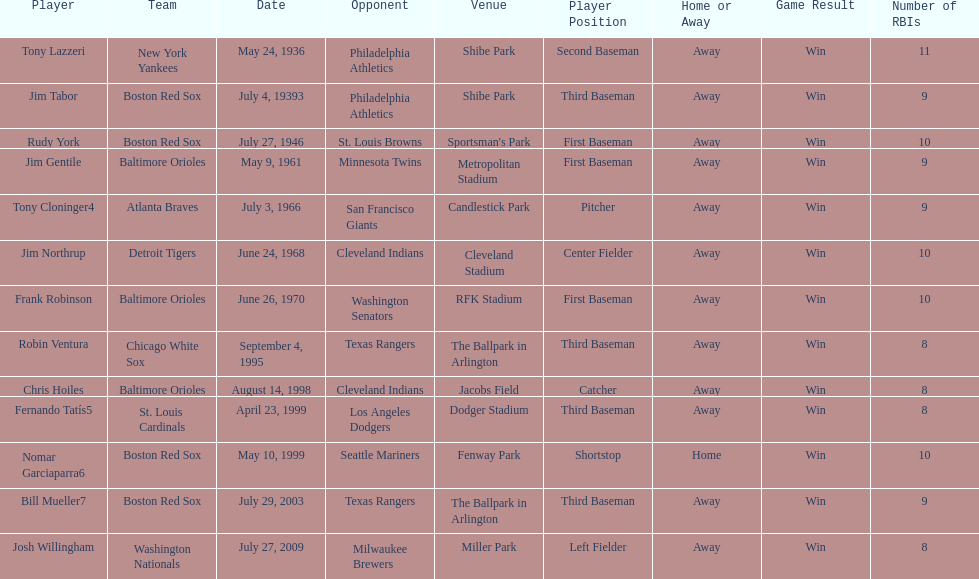On what date did the detroit tigers play the cleveland indians? June 24, 1968. 